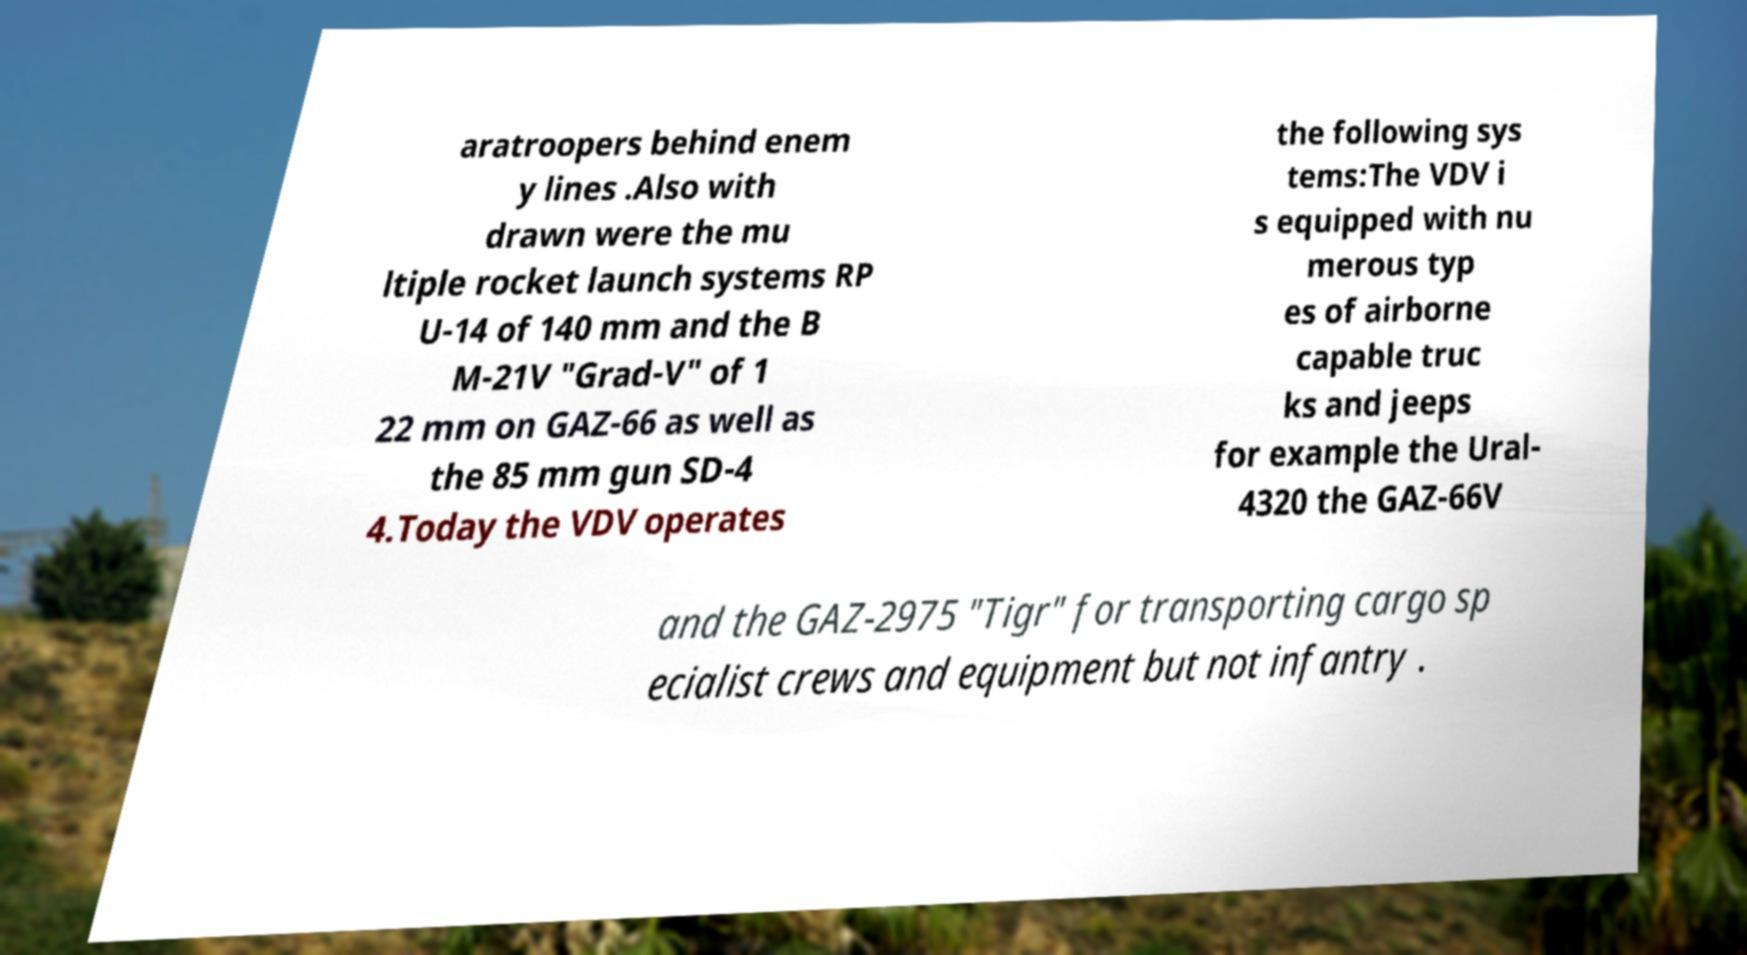There's text embedded in this image that I need extracted. Can you transcribe it verbatim? aratroopers behind enem y lines .Also with drawn were the mu ltiple rocket launch systems RP U-14 of 140 mm and the B M-21V "Grad-V" of 1 22 mm on GAZ-66 as well as the 85 mm gun SD-4 4.Today the VDV operates the following sys tems:The VDV i s equipped with nu merous typ es of airborne capable truc ks and jeeps for example the Ural- 4320 the GAZ-66V and the GAZ-2975 "Tigr" for transporting cargo sp ecialist crews and equipment but not infantry . 